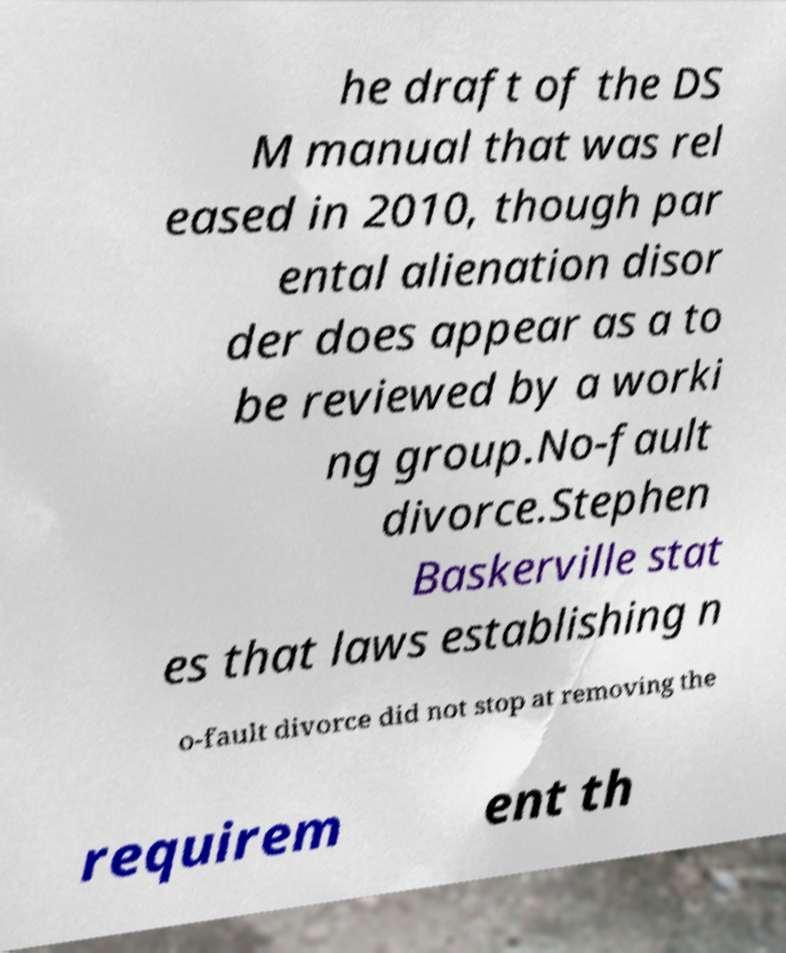Can you accurately transcribe the text from the provided image for me? he draft of the DS M manual that was rel eased in 2010, though par ental alienation disor der does appear as a to be reviewed by a worki ng group.No-fault divorce.Stephen Baskerville stat es that laws establishing n o-fault divorce did not stop at removing the requirem ent th 